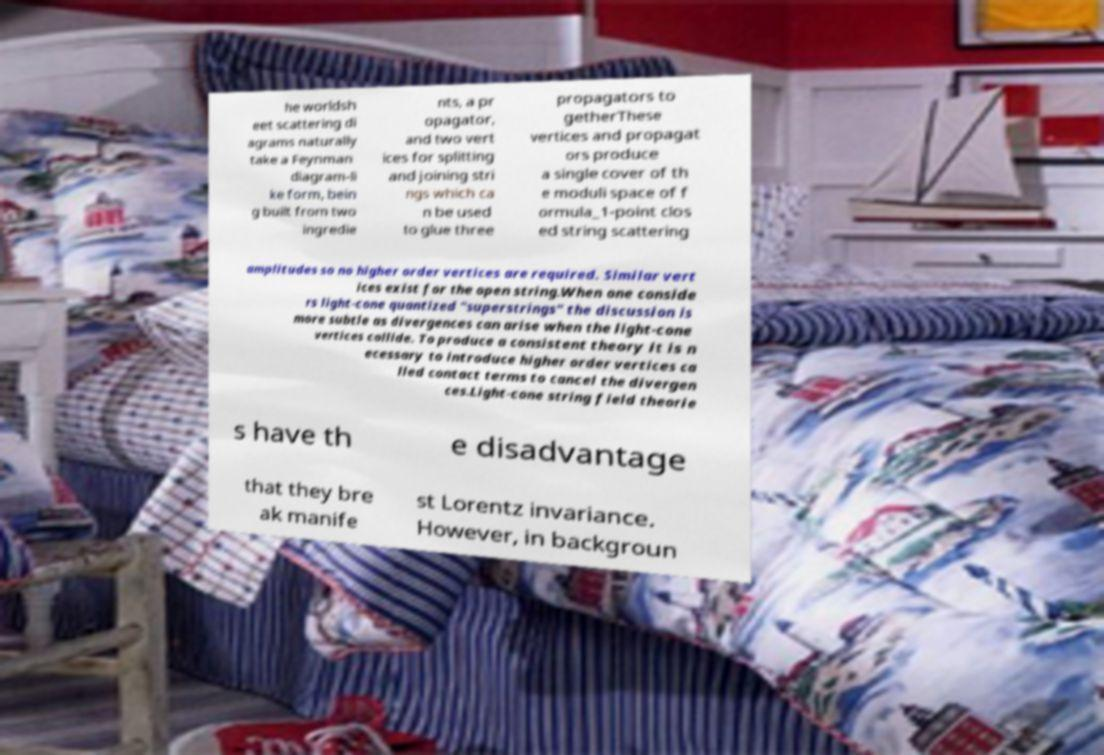I need the written content from this picture converted into text. Can you do that? he worldsh eet scattering di agrams naturally take a Feynman diagram-li ke form, bein g built from two ingredie nts, a pr opagator, and two vert ices for splitting and joining stri ngs which ca n be used to glue three propagators to getherThese vertices and propagat ors produce a single cover of th e moduli space of f ormula_1-point clos ed string scattering amplitudes so no higher order vertices are required. Similar vert ices exist for the open string.When one conside rs light-cone quantized "superstrings" the discussion is more subtle as divergences can arise when the light-cone vertices collide. To produce a consistent theory it is n ecessary to introduce higher order vertices ca lled contact terms to cancel the divergen ces.Light-cone string field theorie s have th e disadvantage that they bre ak manife st Lorentz invariance. However, in backgroun 